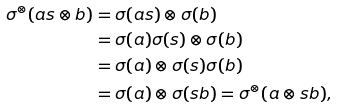Convert formula to latex. <formula><loc_0><loc_0><loc_500><loc_500>\sigma ^ { \otimes } ( a s \otimes b ) & = \sigma ( a s ) \otimes \sigma ( b ) \\ & = \sigma ( a ) \sigma ( s ) \otimes \sigma ( b ) \\ & = \sigma ( a ) \otimes \sigma ( s ) \sigma ( b ) \\ & = \sigma ( a ) \otimes \sigma ( s b ) = \sigma ^ { \otimes } ( a \otimes s b ) ,</formula> 